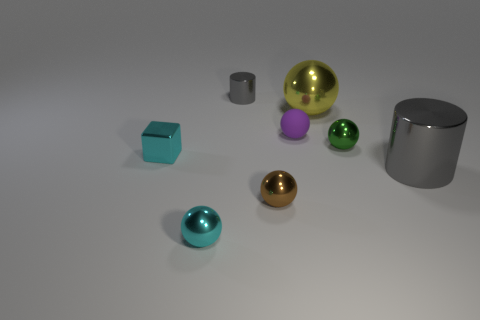Subtract all purple matte spheres. How many spheres are left? 4 Subtract all yellow balls. How many balls are left? 4 Add 1 green shiny things. How many objects exist? 9 Subtract all yellow balls. Subtract all purple cylinders. How many balls are left? 4 Subtract all red metallic cubes. Subtract all cyan cubes. How many objects are left? 7 Add 2 small matte things. How many small matte things are left? 3 Add 3 tiny gray cylinders. How many tiny gray cylinders exist? 4 Subtract 1 green balls. How many objects are left? 7 Subtract all spheres. How many objects are left? 3 